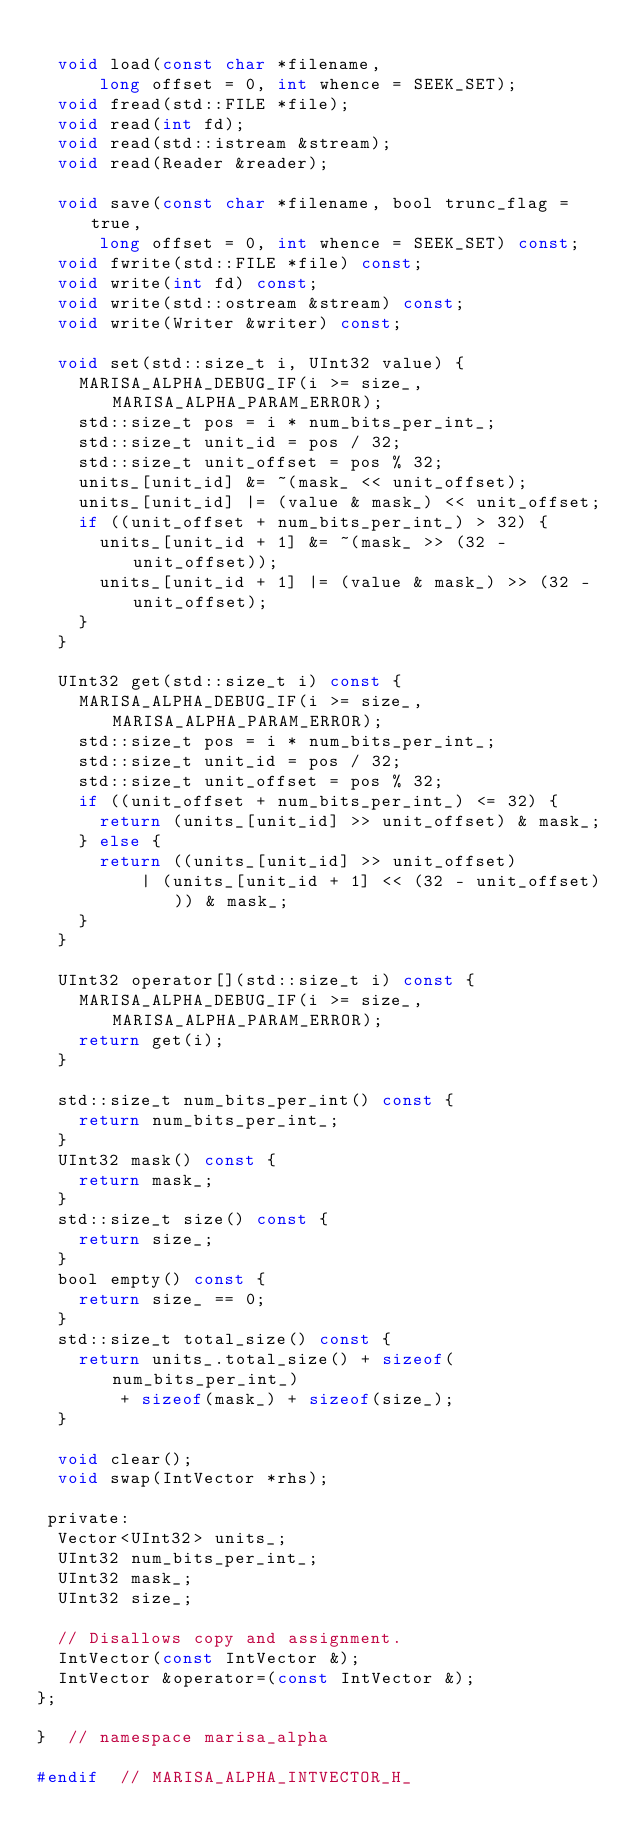<code> <loc_0><loc_0><loc_500><loc_500><_C_>
  void load(const char *filename,
      long offset = 0, int whence = SEEK_SET);
  void fread(std::FILE *file);
  void read(int fd);
  void read(std::istream &stream);
  void read(Reader &reader);

  void save(const char *filename, bool trunc_flag = true,
      long offset = 0, int whence = SEEK_SET) const;
  void fwrite(std::FILE *file) const;
  void write(int fd) const;
  void write(std::ostream &stream) const;
  void write(Writer &writer) const;

  void set(std::size_t i, UInt32 value) {
    MARISA_ALPHA_DEBUG_IF(i >= size_, MARISA_ALPHA_PARAM_ERROR);
    std::size_t pos = i * num_bits_per_int_;
    std::size_t unit_id = pos / 32;
    std::size_t unit_offset = pos % 32;
    units_[unit_id] &= ~(mask_ << unit_offset);
    units_[unit_id] |= (value & mask_) << unit_offset;
    if ((unit_offset + num_bits_per_int_) > 32) {
      units_[unit_id + 1] &= ~(mask_ >> (32 - unit_offset));
      units_[unit_id + 1] |= (value & mask_) >> (32 - unit_offset);
    }
  }

  UInt32 get(std::size_t i) const {
    MARISA_ALPHA_DEBUG_IF(i >= size_, MARISA_ALPHA_PARAM_ERROR);
    std::size_t pos = i * num_bits_per_int_;
    std::size_t unit_id = pos / 32;
    std::size_t unit_offset = pos % 32;
    if ((unit_offset + num_bits_per_int_) <= 32) {
      return (units_[unit_id] >> unit_offset) & mask_;
    } else {
      return ((units_[unit_id] >> unit_offset)
          | (units_[unit_id + 1] << (32 - unit_offset))) & mask_;
    }
  }

  UInt32 operator[](std::size_t i) const {
    MARISA_ALPHA_DEBUG_IF(i >= size_, MARISA_ALPHA_PARAM_ERROR);
    return get(i);
  }

  std::size_t num_bits_per_int() const {
    return num_bits_per_int_;
  }
  UInt32 mask() const {
    return mask_;
  }
  std::size_t size() const {
    return size_;
  }
  bool empty() const {
    return size_ == 0;
  }
  std::size_t total_size() const {
    return units_.total_size() + sizeof(num_bits_per_int_)
        + sizeof(mask_) + sizeof(size_);
  }

  void clear();
  void swap(IntVector *rhs);

 private:
  Vector<UInt32> units_;
  UInt32 num_bits_per_int_;
  UInt32 mask_;
  UInt32 size_;

  // Disallows copy and assignment.
  IntVector(const IntVector &);
  IntVector &operator=(const IntVector &);
};

}  // namespace marisa_alpha

#endif  // MARISA_ALPHA_INTVECTOR_H_
</code> 